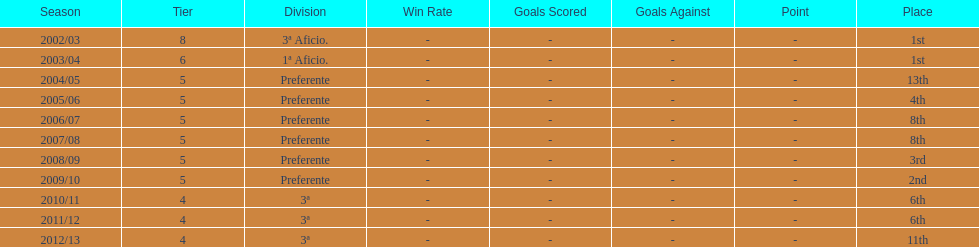What was the number of wins for preferente? 6. 